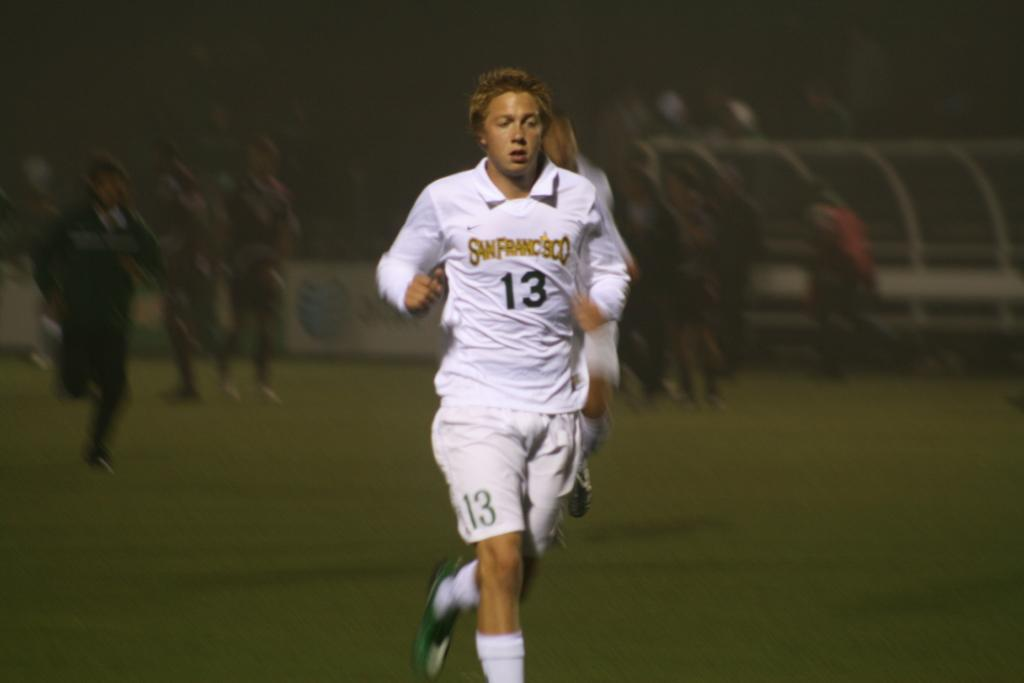<image>
Write a terse but informative summary of the picture. A football player in a white strip bearing the number 13 and San Francisco tuns off the pitch. 